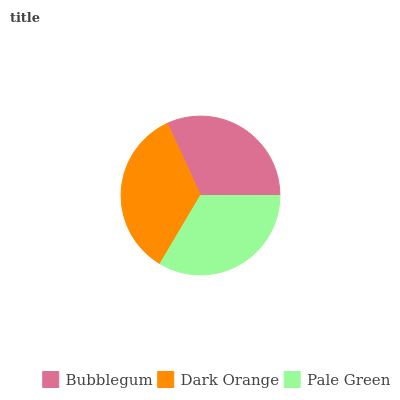Is Bubblegum the minimum?
Answer yes or no. Yes. Is Dark Orange the maximum?
Answer yes or no. Yes. Is Pale Green the minimum?
Answer yes or no. No. Is Pale Green the maximum?
Answer yes or no. No. Is Dark Orange greater than Pale Green?
Answer yes or no. Yes. Is Pale Green less than Dark Orange?
Answer yes or no. Yes. Is Pale Green greater than Dark Orange?
Answer yes or no. No. Is Dark Orange less than Pale Green?
Answer yes or no. No. Is Pale Green the high median?
Answer yes or no. Yes. Is Pale Green the low median?
Answer yes or no. Yes. Is Bubblegum the high median?
Answer yes or no. No. Is Dark Orange the low median?
Answer yes or no. No. 